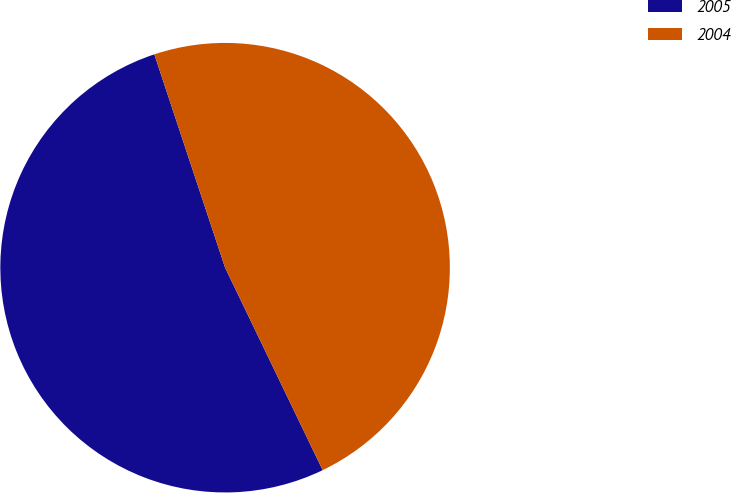Convert chart to OTSL. <chart><loc_0><loc_0><loc_500><loc_500><pie_chart><fcel>2005<fcel>2004<nl><fcel>52.05%<fcel>47.95%<nl></chart> 